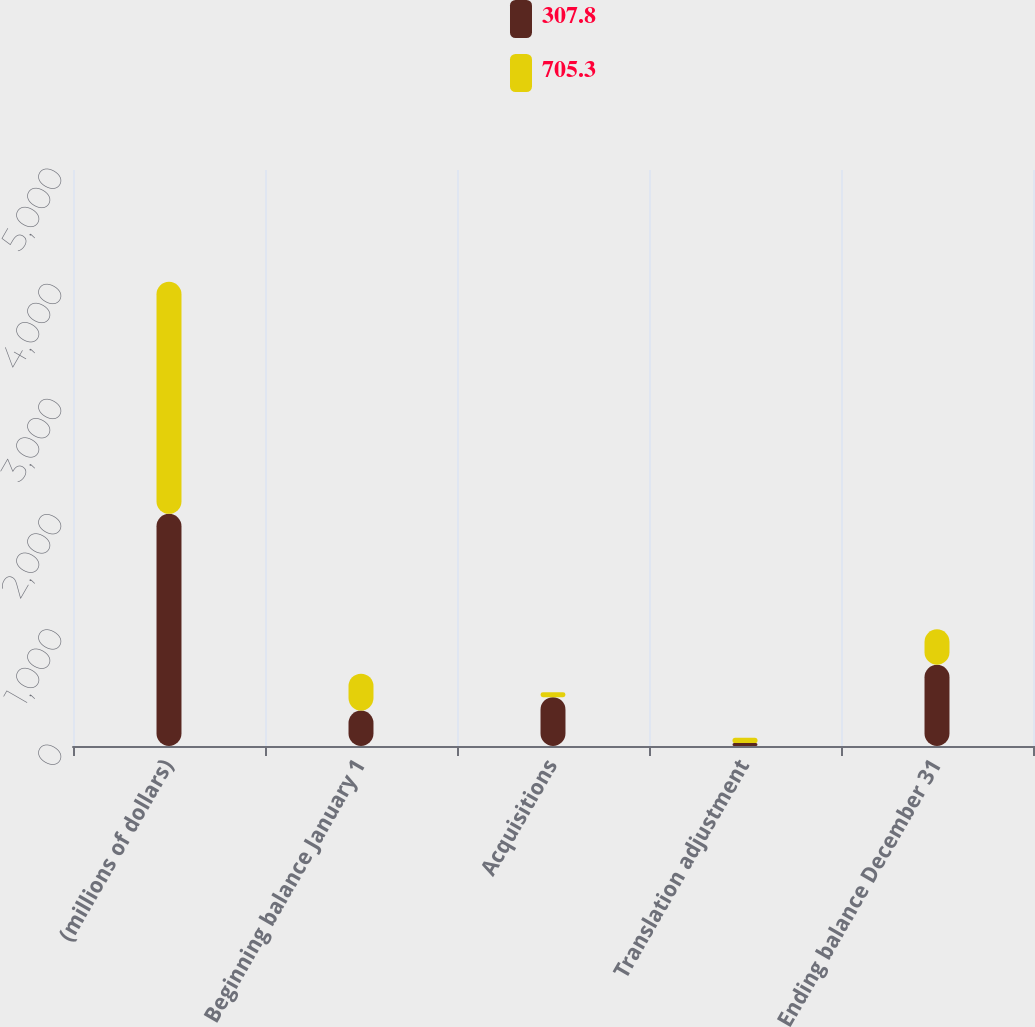Convert chart to OTSL. <chart><loc_0><loc_0><loc_500><loc_500><stacked_bar_chart><ecel><fcel>(millions of dollars)<fcel>Beginning balance January 1<fcel>Acquisitions<fcel>Translation adjustment<fcel>Ending balance December 31<nl><fcel>307.8<fcel>2015<fcel>307.8<fcel>423.8<fcel>26.3<fcel>705.3<nl><fcel>705.3<fcel>2014<fcel>320.3<fcel>42.7<fcel>44.9<fcel>307.8<nl></chart> 